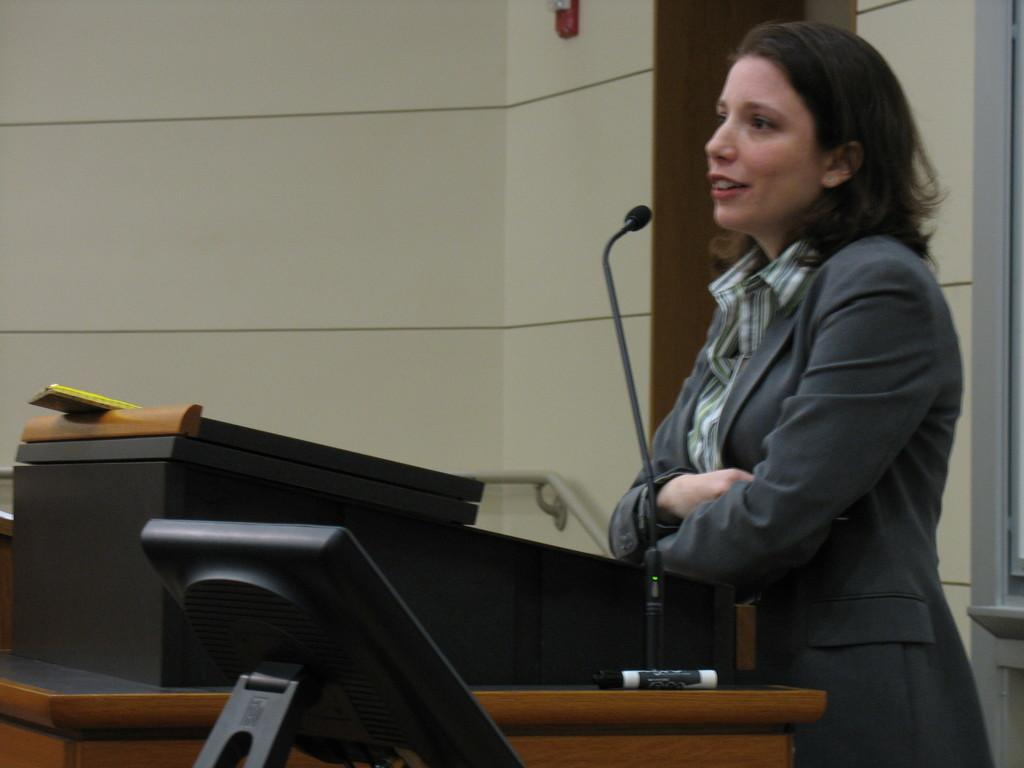Who or what is on the right side of the image? There is a person on the right side of the image. What is the person wearing? The person is wearing a suit. What object is in front of the person? There is a microphone in front of the person. What is behind the person in the image? There is a wall behind the person. What type of picture is hanging on the wall behind the person? There is no picture mentioned in the facts provided, so we cannot determine if there is a picture hanging on the wall behind the person. 